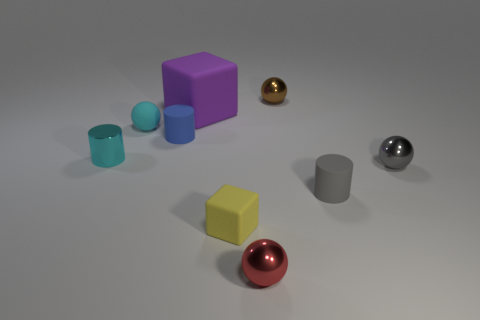Subtract 1 balls. How many balls are left? 3 Subtract all cylinders. How many objects are left? 6 Subtract all brown metallic objects. Subtract all purple rubber things. How many objects are left? 7 Add 6 tiny gray balls. How many tiny gray balls are left? 7 Add 3 small cyan balls. How many small cyan balls exist? 4 Subtract 1 brown balls. How many objects are left? 8 